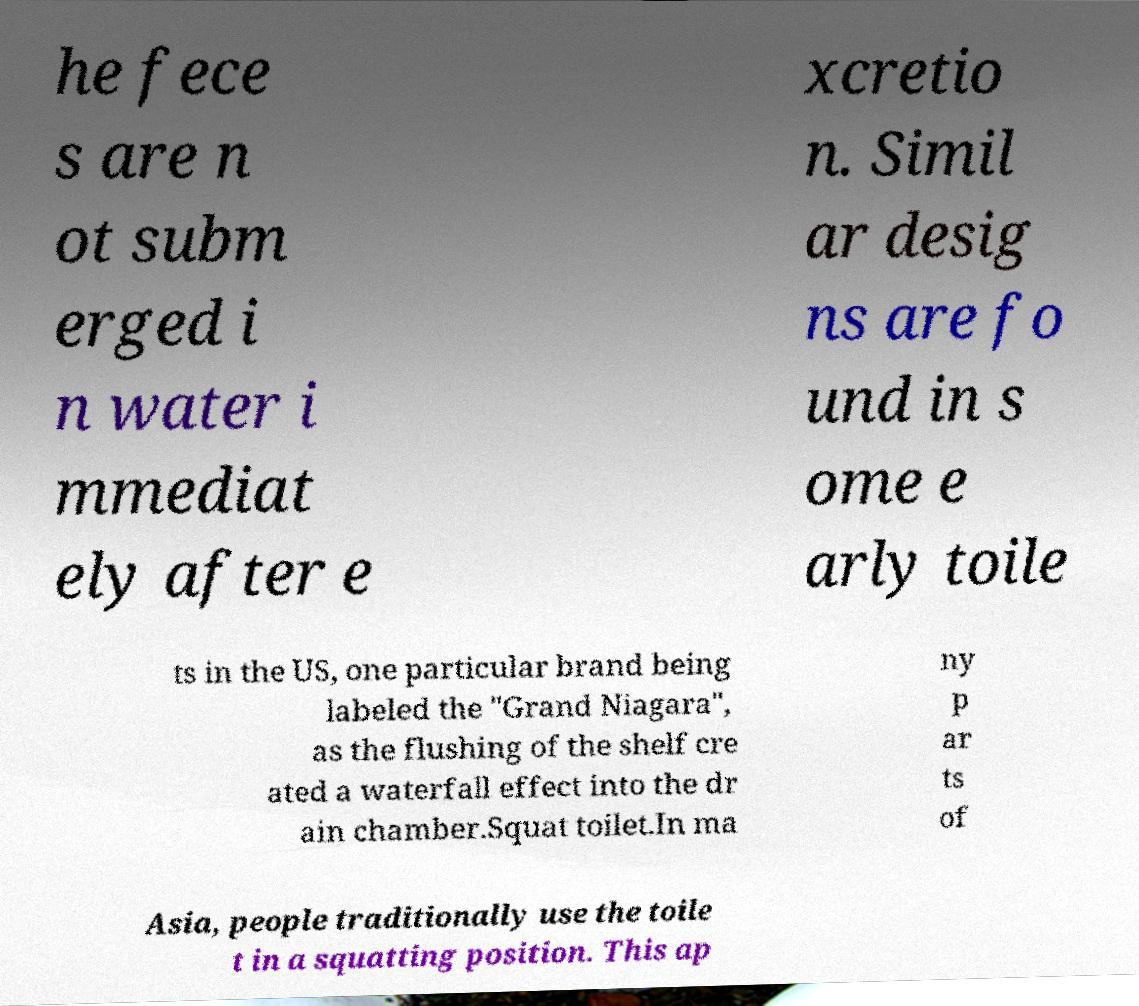What messages or text are displayed in this image? I need them in a readable, typed format. he fece s are n ot subm erged i n water i mmediat ely after e xcretio n. Simil ar desig ns are fo und in s ome e arly toile ts in the US, one particular brand being labeled the "Grand Niagara", as the flushing of the shelf cre ated a waterfall effect into the dr ain chamber.Squat toilet.In ma ny p ar ts of Asia, people traditionally use the toile t in a squatting position. This ap 